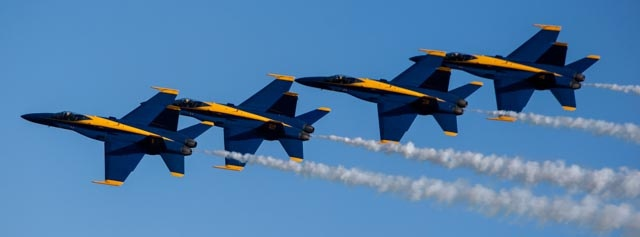Describe the objects in this image and their specific colors. I can see airplane in gray, black, and navy tones, airplane in gray, navy, black, and orange tones, airplane in gray, navy, black, and orange tones, and airplane in gray, navy, black, and orange tones in this image. 